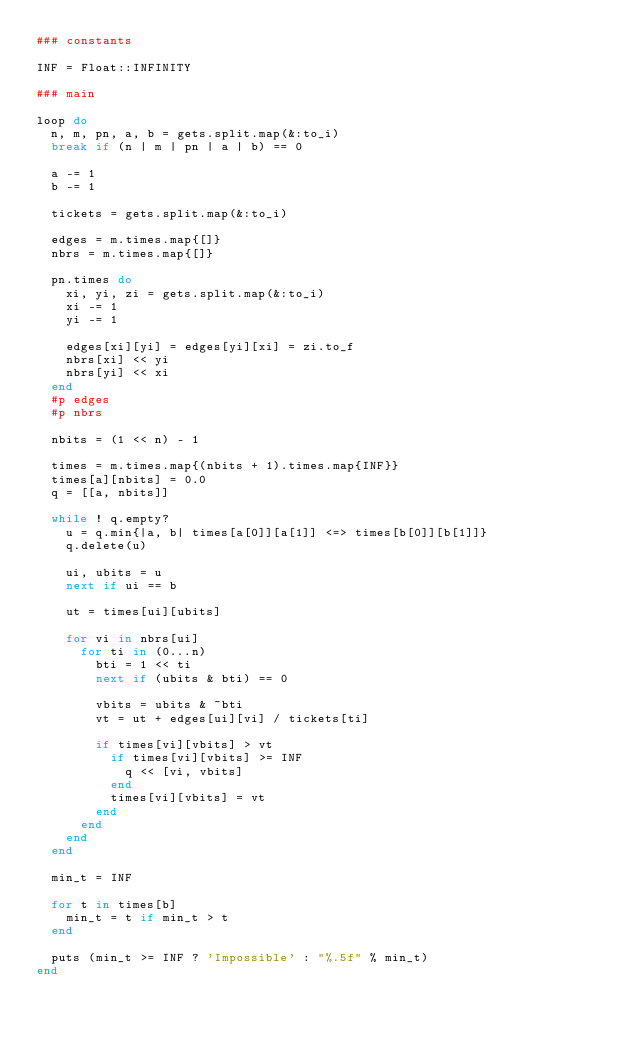<code> <loc_0><loc_0><loc_500><loc_500><_Ruby_>### constants

INF = Float::INFINITY

### main

loop do
  n, m, pn, a, b = gets.split.map(&:to_i)
  break if (n | m | pn | a | b) == 0

  a -= 1
  b -= 1

  tickets = gets.split.map(&:to_i)

  edges = m.times.map{[]}
  nbrs = m.times.map{[]}

  pn.times do
    xi, yi, zi = gets.split.map(&:to_i)
    xi -= 1
    yi -= 1

    edges[xi][yi] = edges[yi][xi] = zi.to_f
    nbrs[xi] << yi
    nbrs[yi] << xi
  end
  #p edges
  #p nbrs

  nbits = (1 << n) - 1

  times = m.times.map{(nbits + 1).times.map{INF}}
  times[a][nbits] = 0.0
  q = [[a, nbits]]

  while ! q.empty?
    u = q.min{|a, b| times[a[0]][a[1]] <=> times[b[0]][b[1]]}
    q.delete(u)

    ui, ubits = u
    next if ui == b

    ut = times[ui][ubits]

    for vi in nbrs[ui]
      for ti in (0...n)
        bti = 1 << ti
        next if (ubits & bti) == 0

        vbits = ubits & ~bti
        vt = ut + edges[ui][vi] / tickets[ti]

        if times[vi][vbits] > vt
          if times[vi][vbits] >= INF
            q << [vi, vbits]
          end
          times[vi][vbits] = vt
        end
      end
    end
  end

  min_t = INF

  for t in times[b]
    min_t = t if min_t > t
  end

  puts (min_t >= INF ? 'Impossible' : "%.5f" % min_t)
end</code> 